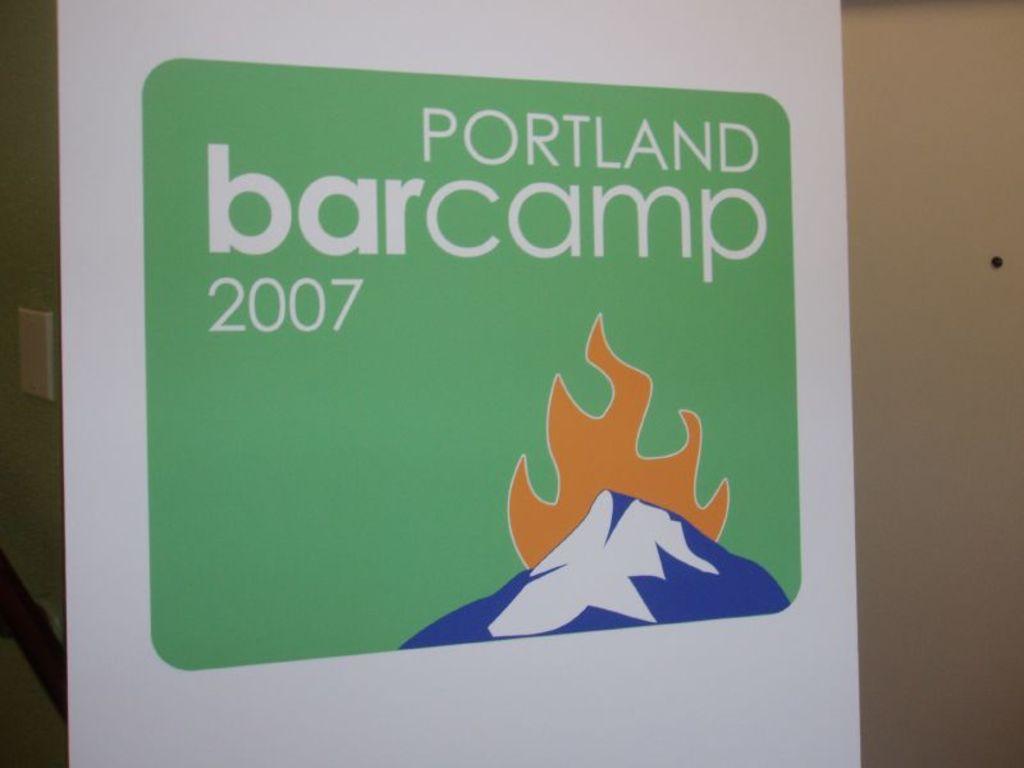What year was this barcamp?
Offer a very short reply. 2007. What year is on the poster?
Offer a very short reply. 2007. 